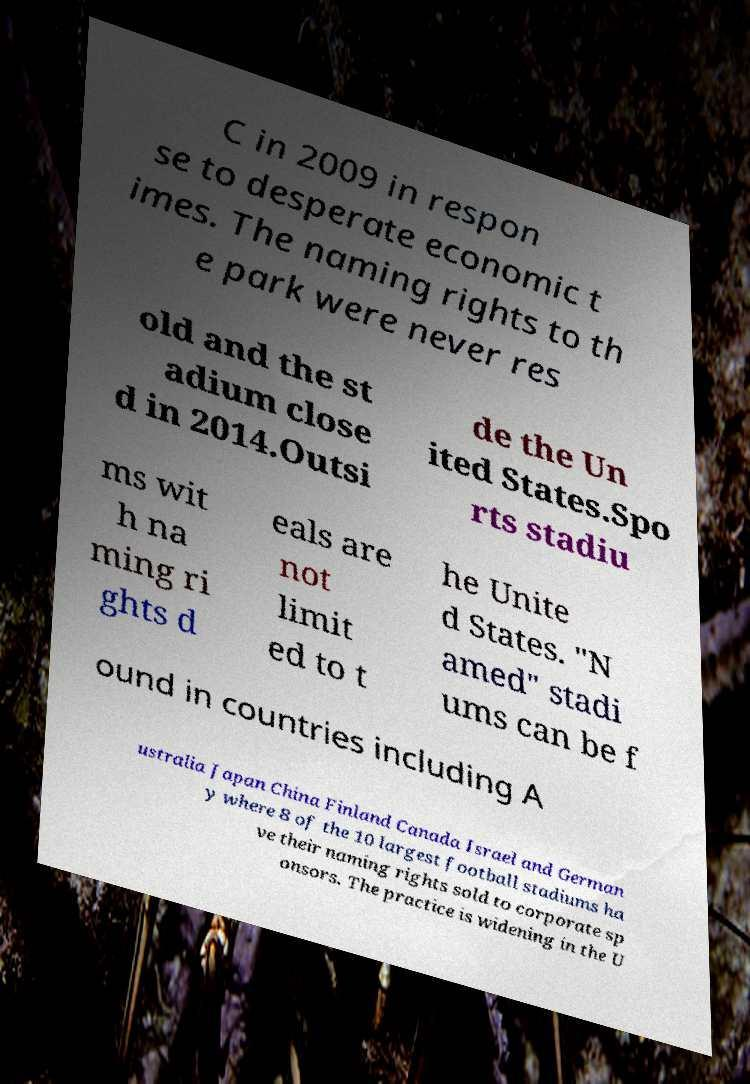What messages or text are displayed in this image? I need them in a readable, typed format. C in 2009 in respon se to desperate economic t imes. The naming rights to th e park were never res old and the st adium close d in 2014.Outsi de the Un ited States.Spo rts stadiu ms wit h na ming ri ghts d eals are not limit ed to t he Unite d States. "N amed" stadi ums can be f ound in countries including A ustralia Japan China Finland Canada Israel and German y where 8 of the 10 largest football stadiums ha ve their naming rights sold to corporate sp onsors. The practice is widening in the U 